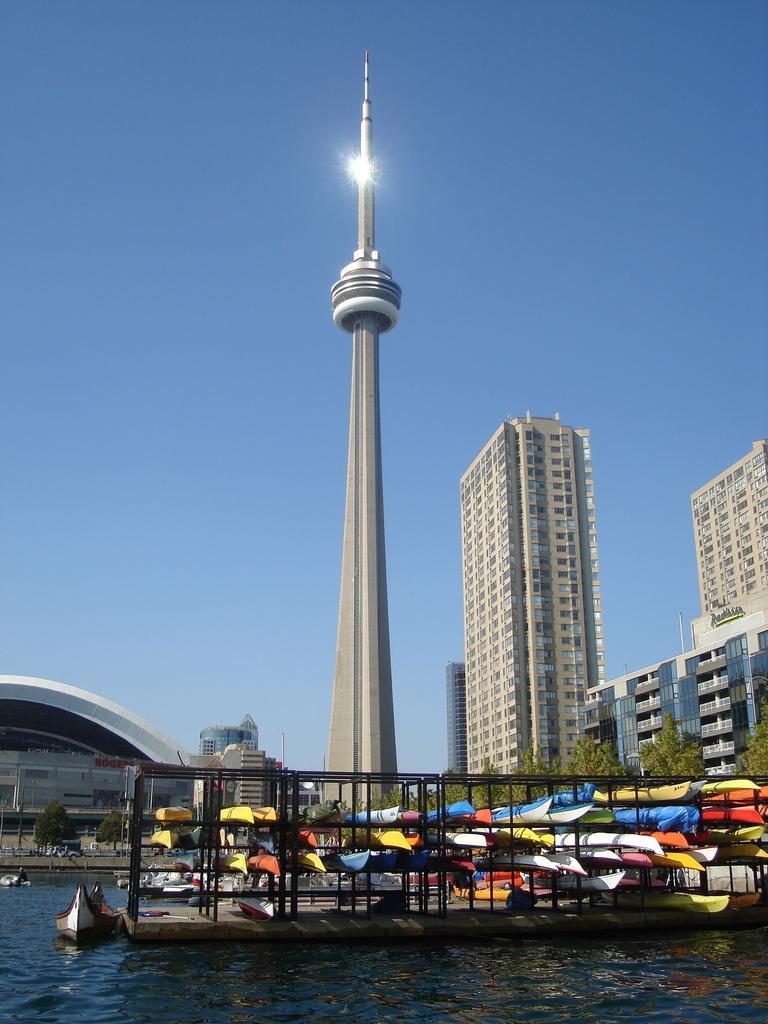Describe this image in one or two sentences. In this image I can see buildings, trees, a tower and boats on the water. In the background I can see the sky. 